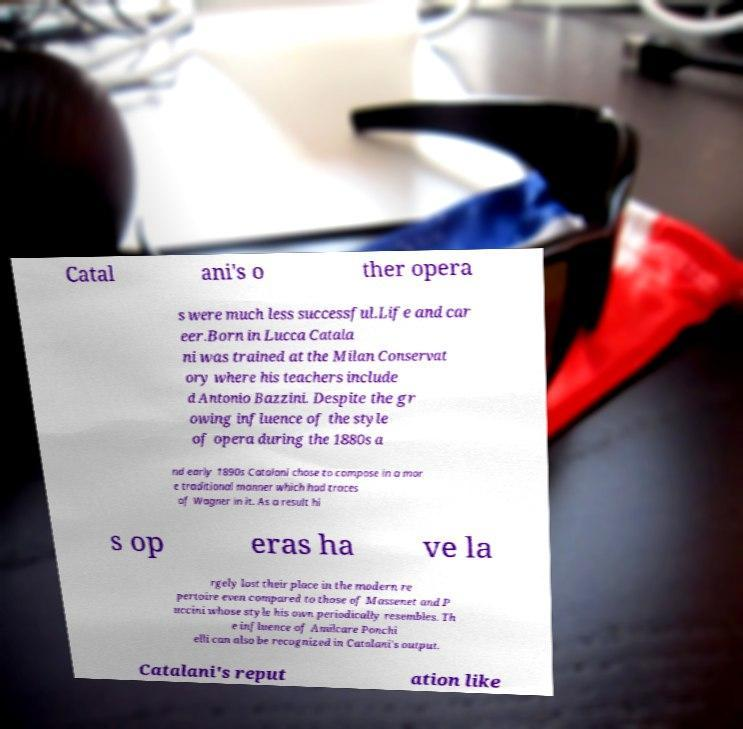Could you assist in decoding the text presented in this image and type it out clearly? Catal ani's o ther opera s were much less successful.Life and car eer.Born in Lucca Catala ni was trained at the Milan Conservat ory where his teachers include d Antonio Bazzini. Despite the gr owing influence of the style of opera during the 1880s a nd early 1890s Catalani chose to compose in a mor e traditional manner which had traces of Wagner in it. As a result hi s op eras ha ve la rgely lost their place in the modern re pertoire even compared to those of Massenet and P uccini whose style his own periodically resembles. Th e influence of Amilcare Ponchi elli can also be recognized in Catalani's output. Catalani's reput ation like 